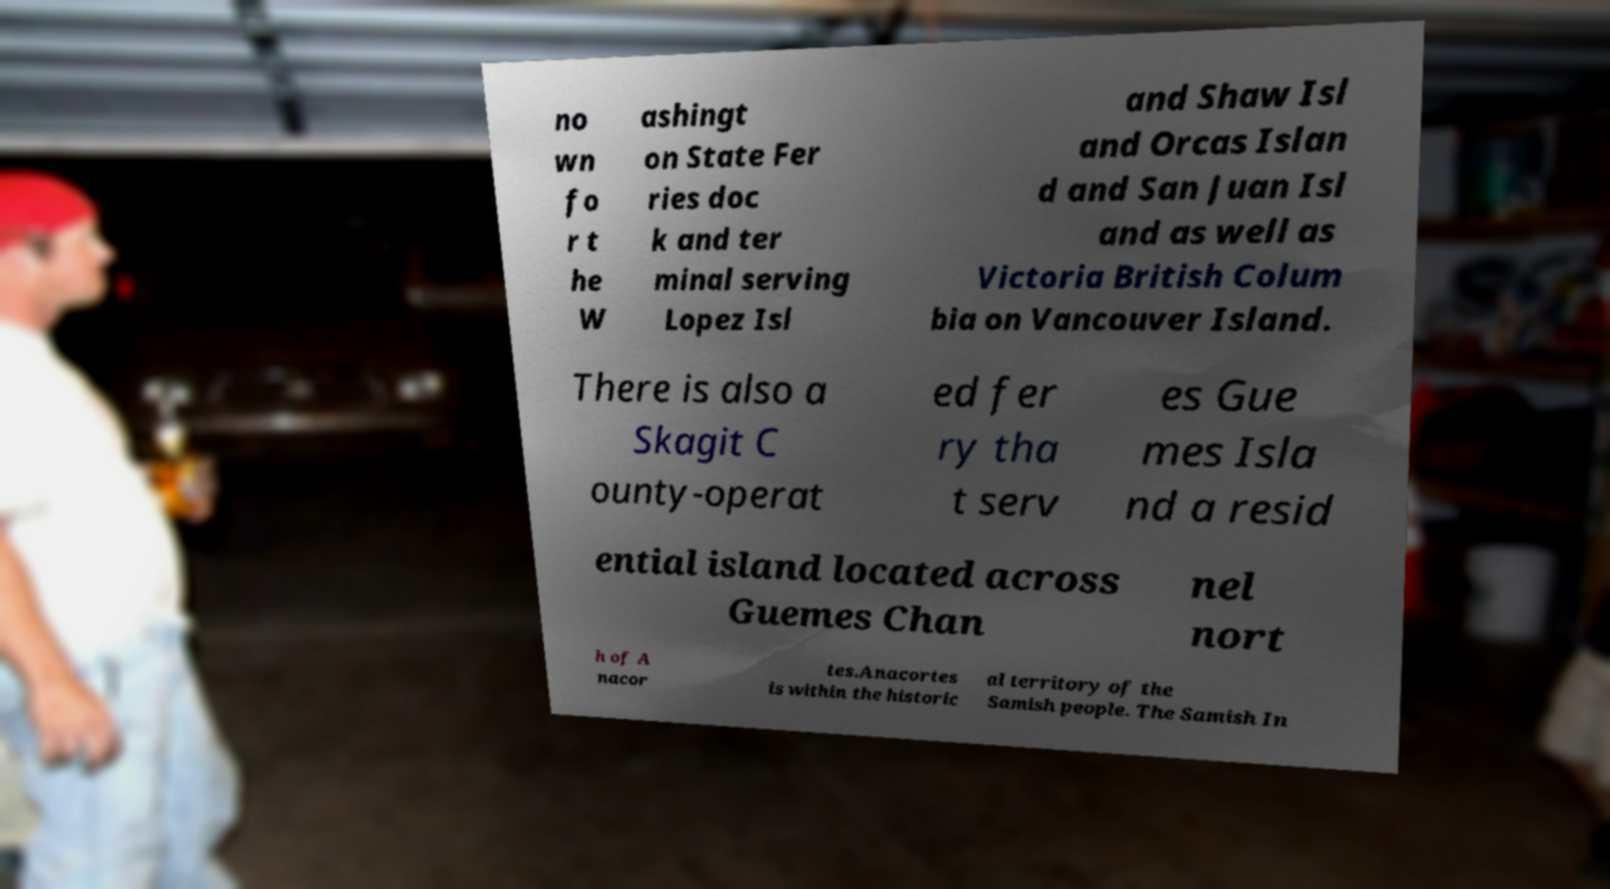There's text embedded in this image that I need extracted. Can you transcribe it verbatim? no wn fo r t he W ashingt on State Fer ries doc k and ter minal serving Lopez Isl and Shaw Isl and Orcas Islan d and San Juan Isl and as well as Victoria British Colum bia on Vancouver Island. There is also a Skagit C ounty-operat ed fer ry tha t serv es Gue mes Isla nd a resid ential island located across Guemes Chan nel nort h of A nacor tes.Anacortes is within the historic al territory of the Samish people. The Samish In 